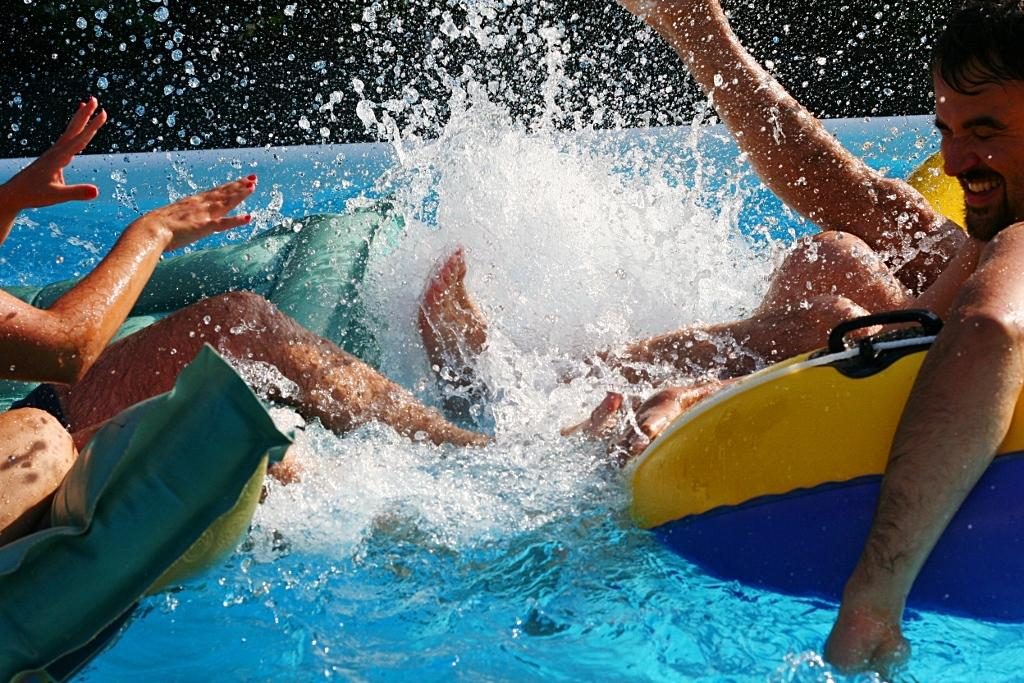What is the primary element in the image? There is water in the image. What are the people doing in the water? There are people on tubes in the water. What type of box is being used to sort the son's toys in the image? There is no box or son present in the image; it only features water and people on tubes. 